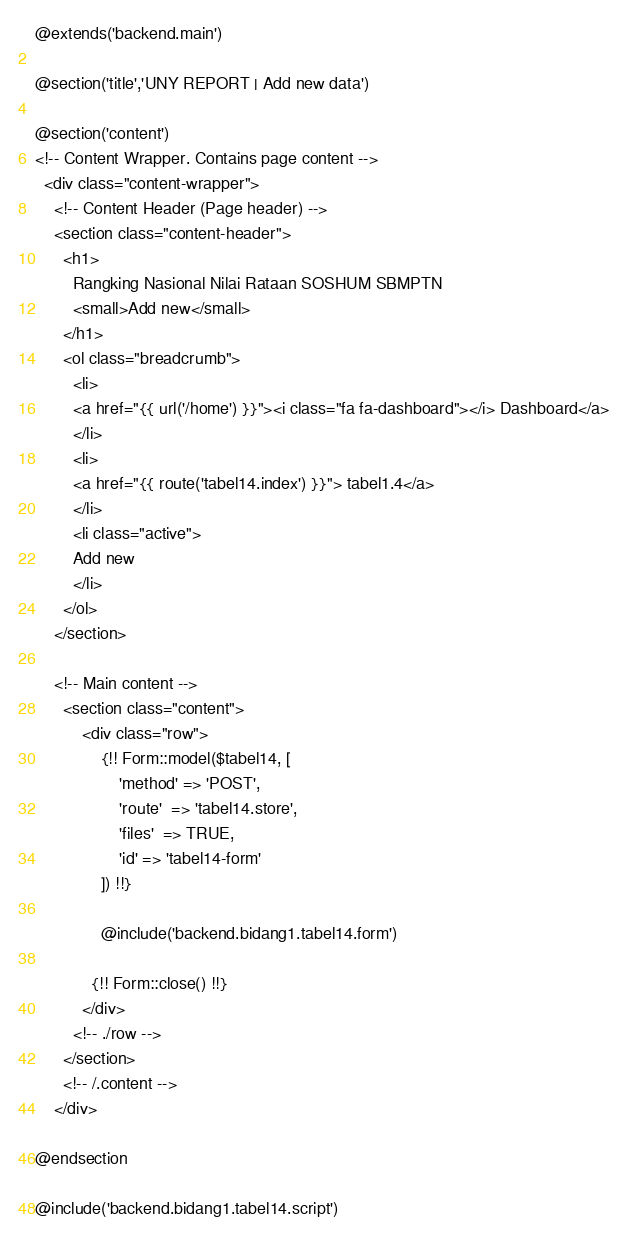<code> <loc_0><loc_0><loc_500><loc_500><_PHP_>@extends('backend.main')

@section('title','UNY REPORT | Add new data')

@section('content')
<!-- Content Wrapper. Contains page content -->
  <div class="content-wrapper">
    <!-- Content Header (Page header) -->
    <section class="content-header">
      <h1>
        Rangking Nasional Nilai Rataan SOSHUM SBMPTN
        <small>Add new</small>
      </h1>
      <ol class="breadcrumb">
        <li>
        <a href="{{ url('/home') }}"><i class="fa fa-dashboard"></i> Dashboard</a>
        </li>
        <li>
        <a href="{{ route('tabel14.index') }}"> tabel1.4</a>
        </li>
        <li class="active">
        Add new
        </li>
      </ol>
    </section>

    <!-- Main content -->
      <section class="content">
          <div class="row">
              {!! Form::model($tabel14, [
                  'method' => 'POST',
                  'route'  => 'tabel14.store',
                  'files'  => TRUE,
                  'id' => 'tabel14-form'
              ]) !!}

              @include('backend.bidang1.tabel14.form')

            {!! Form::close() !!}
          </div>
        <!-- ./row -->
      </section>
      <!-- /.content -->
    </div>

@endsection

@include('backend.bidang1.tabel14.script')

</code> 